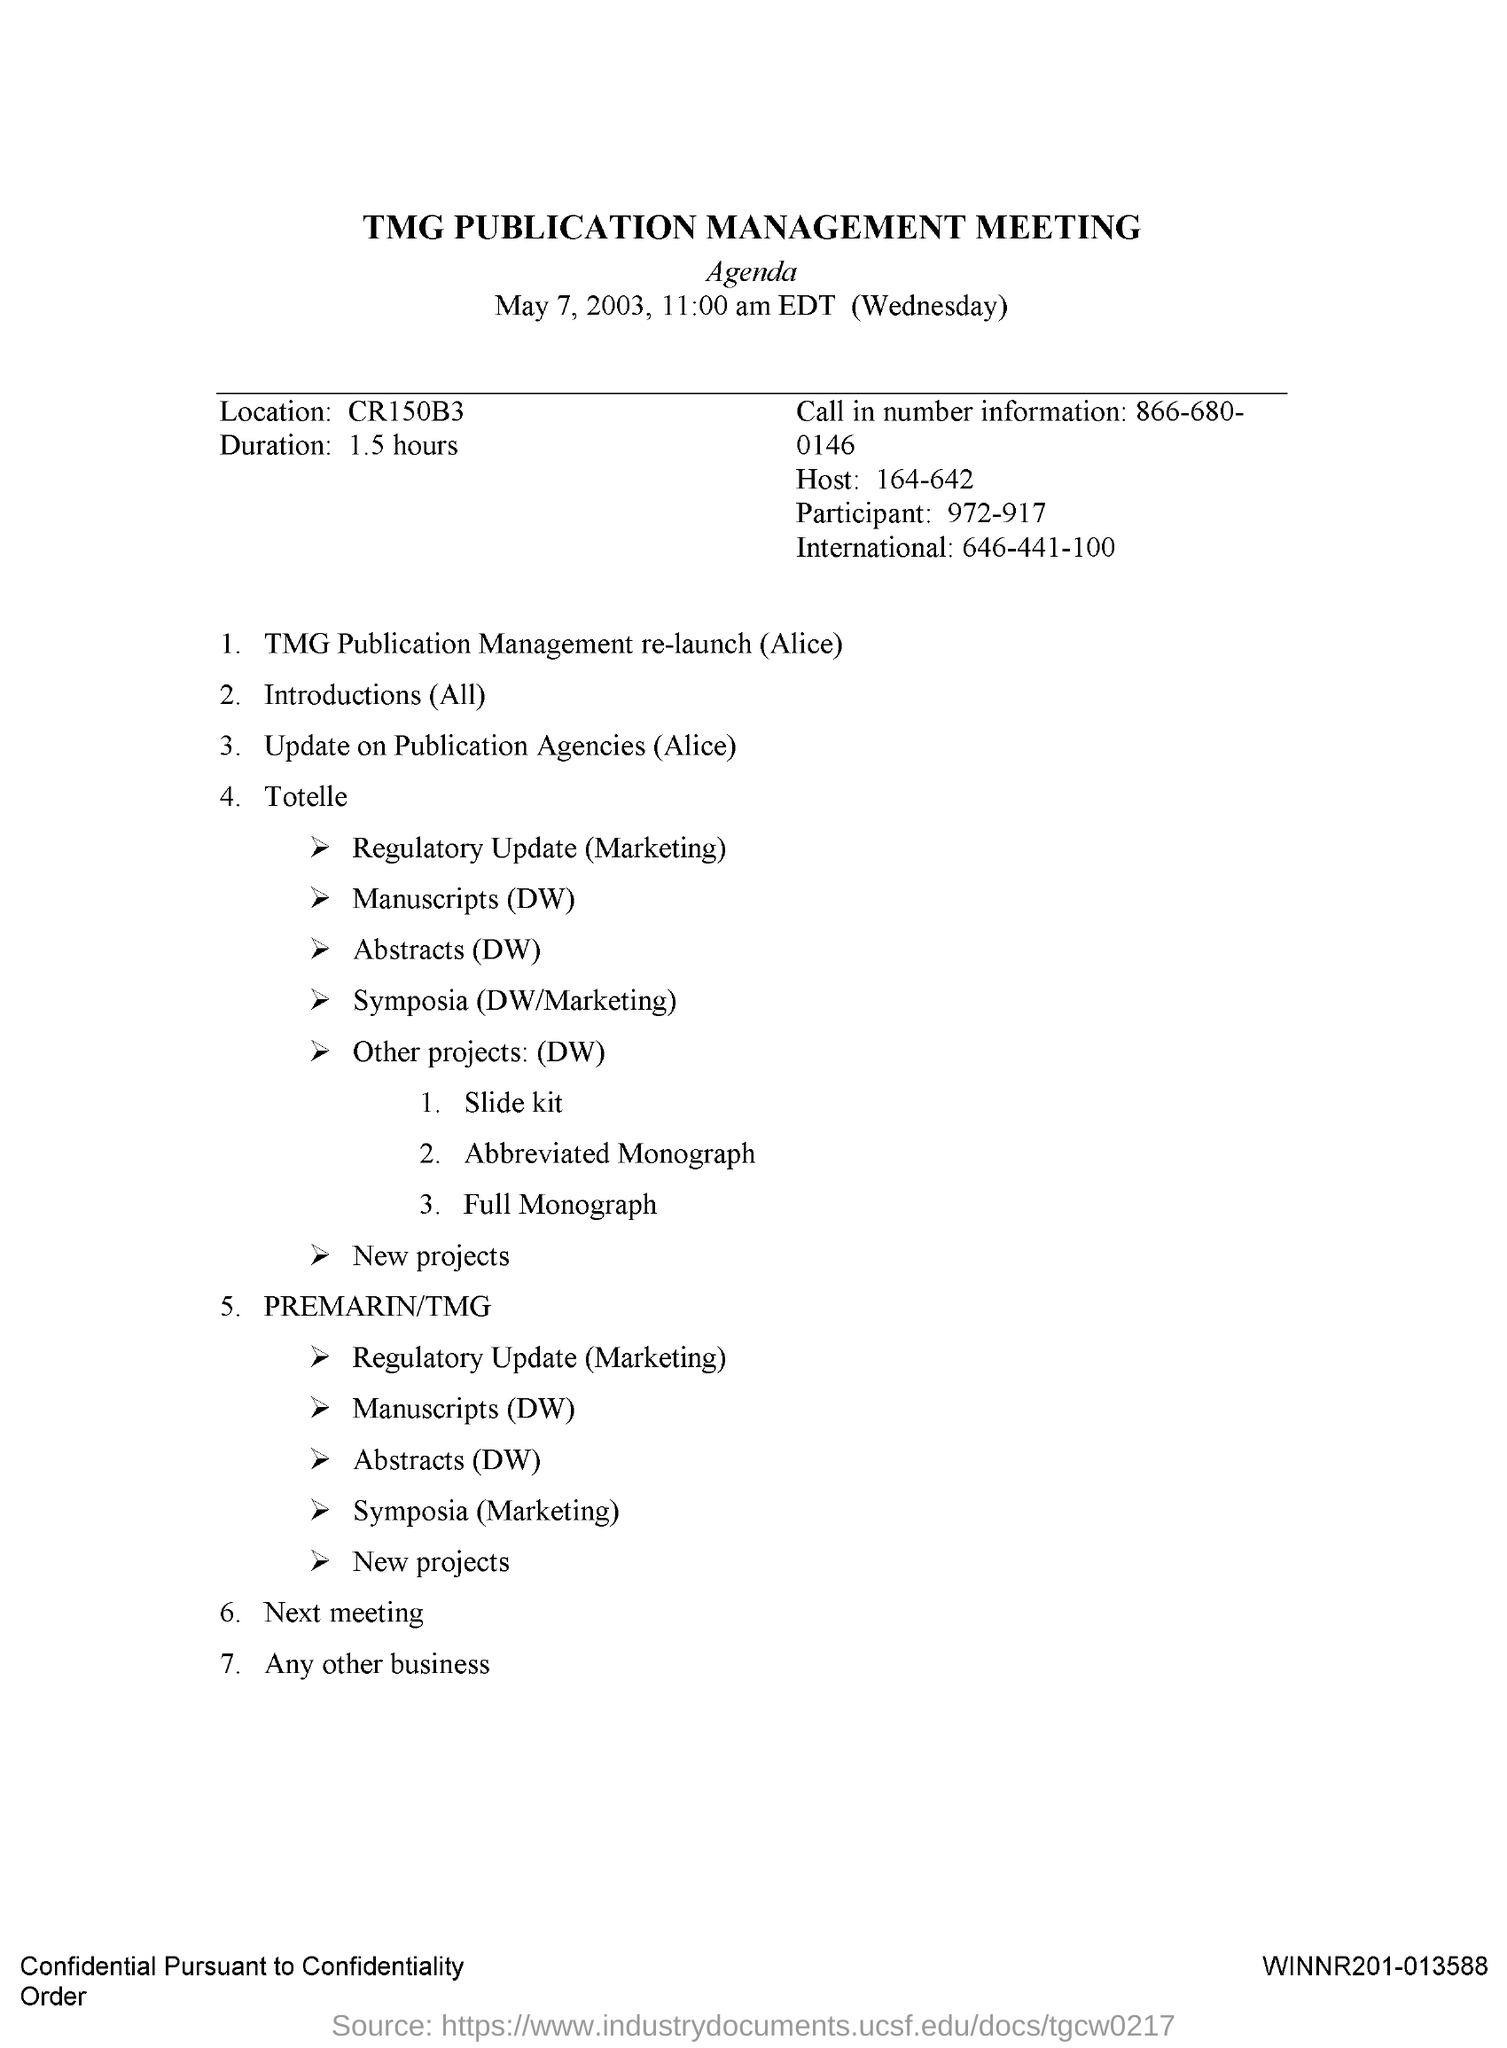When is the TMG Publication Management Meeting held?
Offer a very short reply. May 7, 2003. What is the Call in Number information?
Provide a succinct answer. 866-680-0146. 